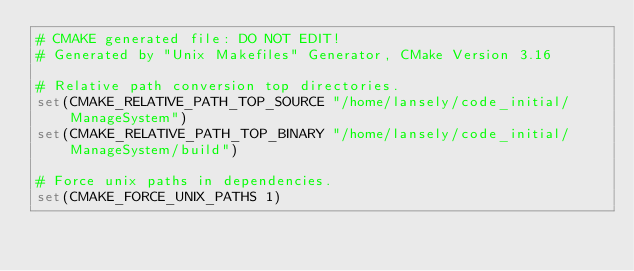Convert code to text. <code><loc_0><loc_0><loc_500><loc_500><_CMake_># CMAKE generated file: DO NOT EDIT!
# Generated by "Unix Makefiles" Generator, CMake Version 3.16

# Relative path conversion top directories.
set(CMAKE_RELATIVE_PATH_TOP_SOURCE "/home/lansely/code_initial/ManageSystem")
set(CMAKE_RELATIVE_PATH_TOP_BINARY "/home/lansely/code_initial/ManageSystem/build")

# Force unix paths in dependencies.
set(CMAKE_FORCE_UNIX_PATHS 1)

</code> 